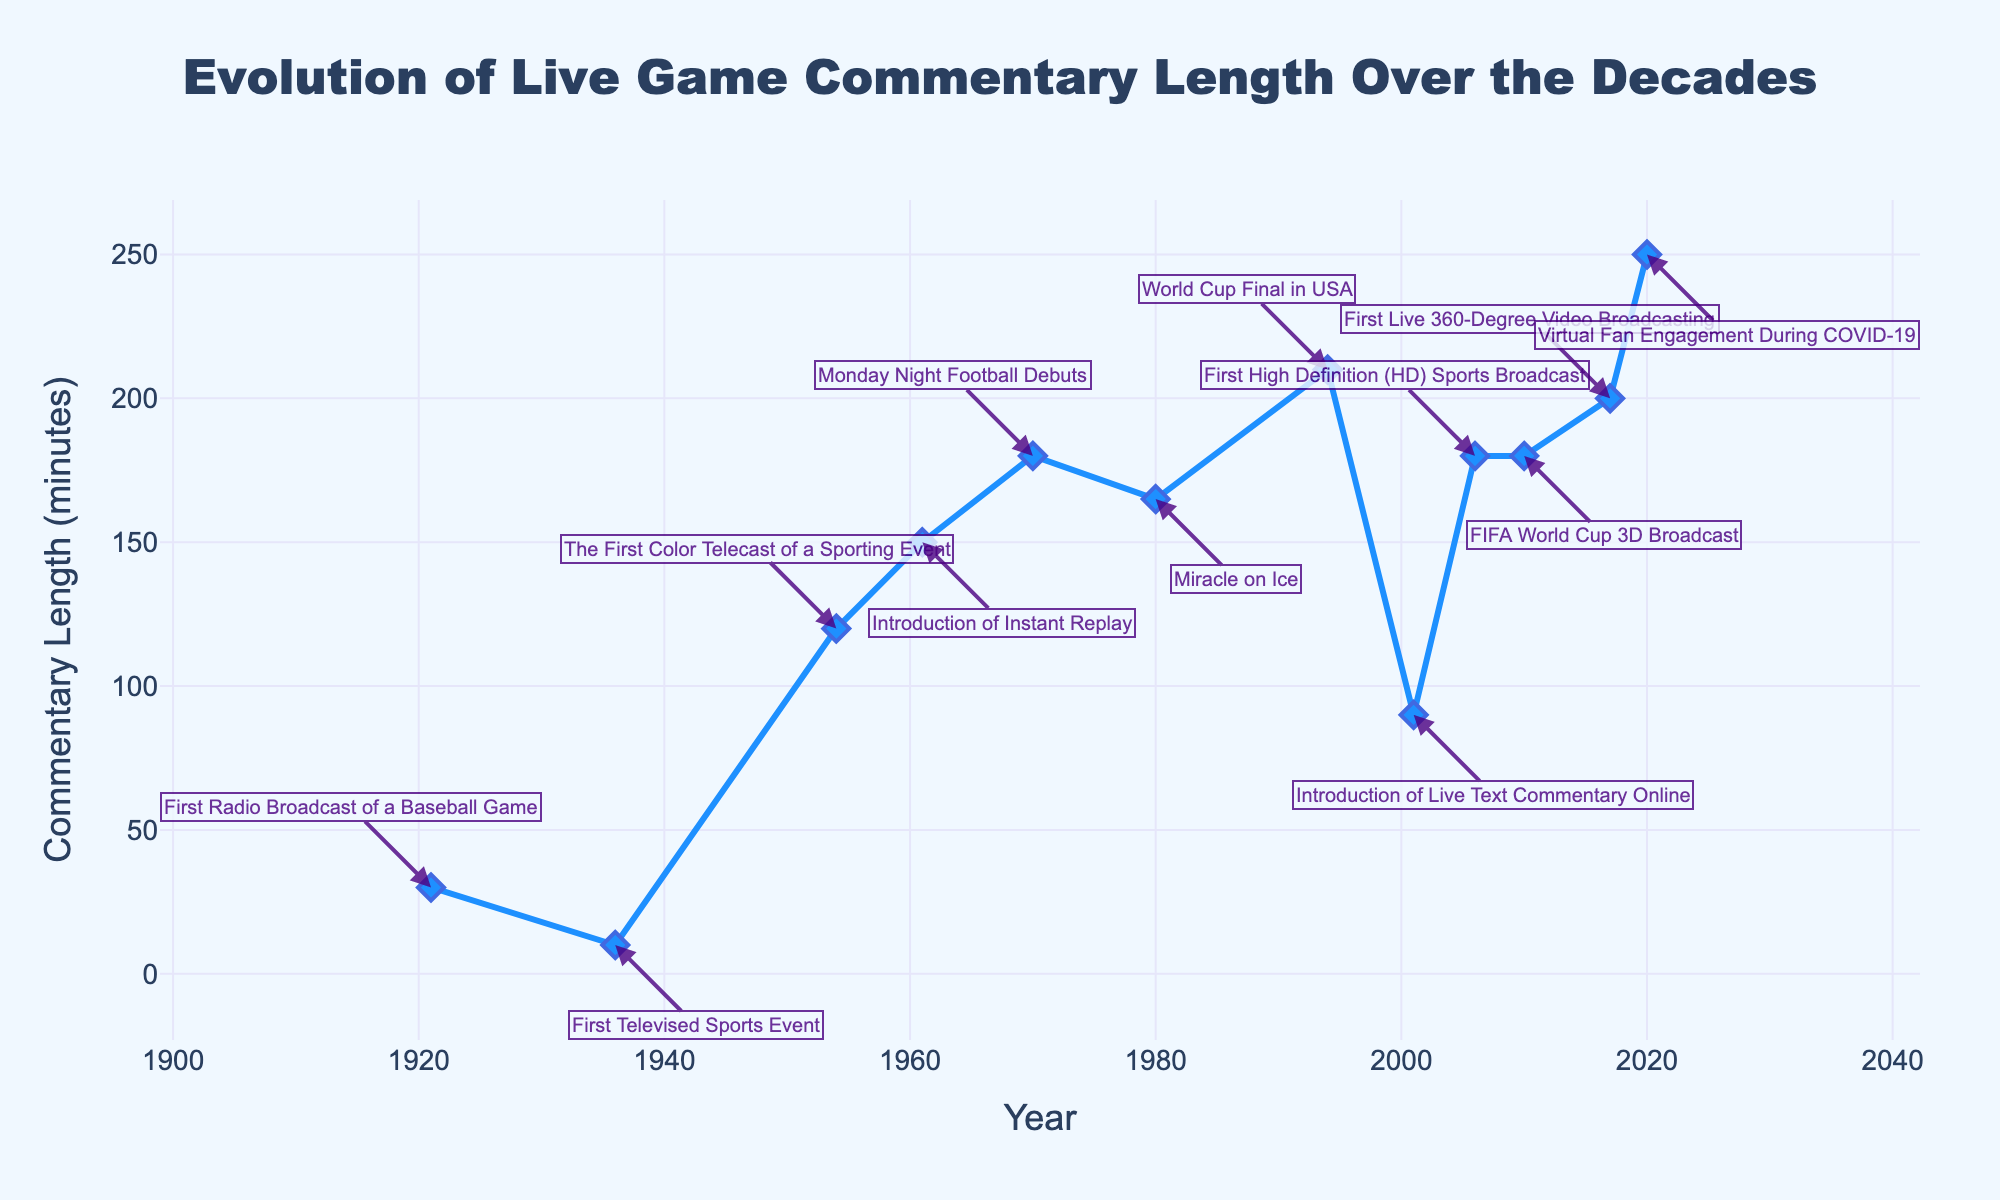What's the title of the figure? Check the top-center of the figure for the text displayed as the title.
Answer: Evolution of Live Game Commentary Length Over the Decades What is the y-axis representing? Look at the label on the vertical axis of the figure.
Answer: Commentary Length (minutes) How many events are annotated in the plot? Count the number of text annotations in the plot.
Answer: 12 Which year had the longest commentary length? Look for the highest point along the y-axis and note the corresponding year.
Answer: 2020 How much longer was the commentary in 2020 compared to 1921? Subtract the commentary length in 1921 from the length in 2020 (250 - 30).
Answer: 220 minutes What is the shortest commentary length recorded in which year? Identify the lowest point along the y-axis and note the corresponding year and length.
Answer: 1936, 10 minutes What event took place in 1954, and how long was its commentary? Locate the annotation for 1954 and read the associated event and commentary length.
Answer: The First Color Telecast of a Sporting Event, 120 minutes Which two years had a commentary length of 180 minutes, and what were the events? Find and list the points on the y-axis with 180 minutes and check the associated years and events.
Answer: 1970, Monday Night Football Debuts; 2006, First High Definition (HD) Sports Broadcast; 2010, FIFA World Cup 3D Broadcast How has the commentary length evolved from the 1930s to the 2000s? Note the trend and changes in commentary length by comparing data points from each decade.
Answer: It increased from 10 minutes in 1936 to 250 minutes in 2020, showing a general upward trend 